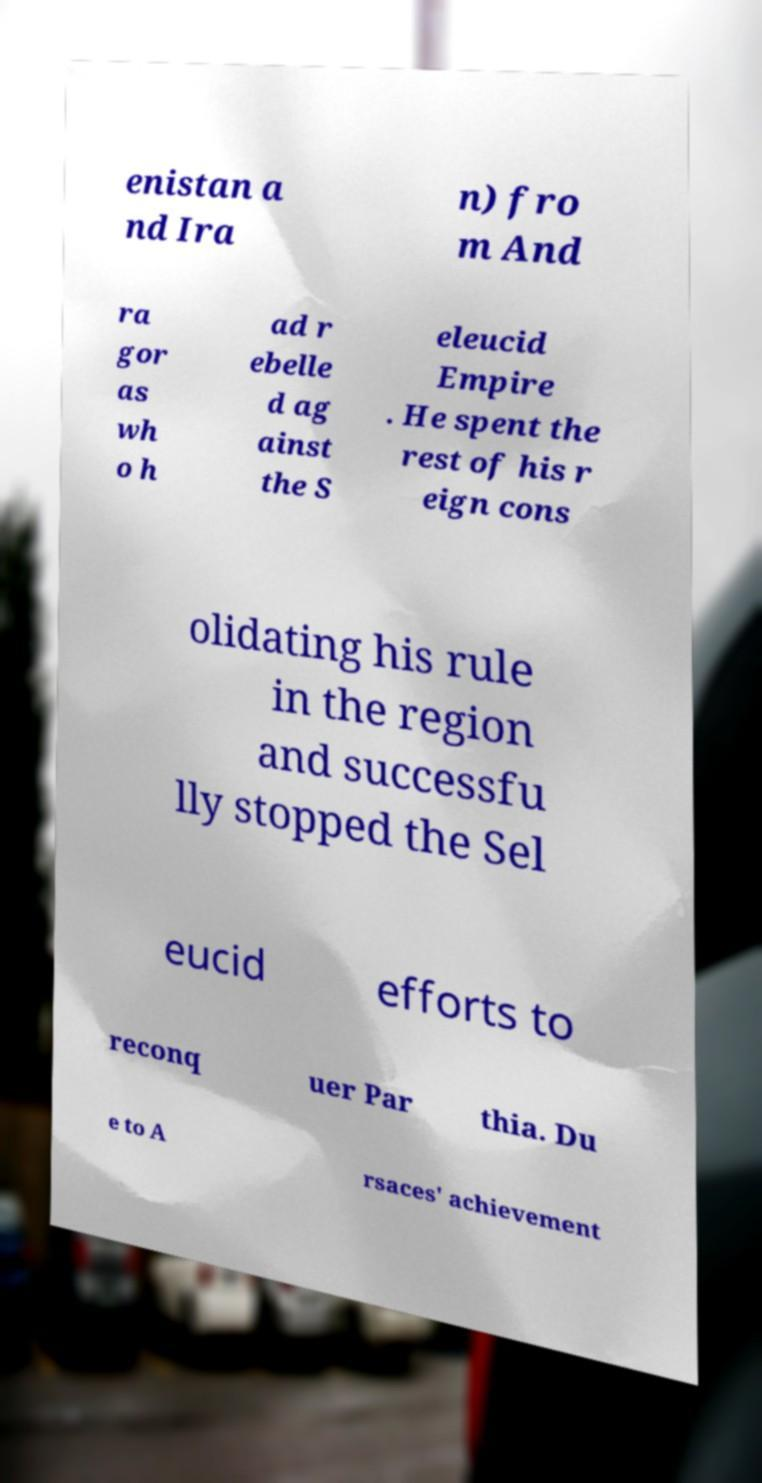Can you read and provide the text displayed in the image?This photo seems to have some interesting text. Can you extract and type it out for me? enistan a nd Ira n) fro m And ra gor as wh o h ad r ebelle d ag ainst the S eleucid Empire . He spent the rest of his r eign cons olidating his rule in the region and successfu lly stopped the Sel eucid efforts to reconq uer Par thia. Du e to A rsaces' achievement 